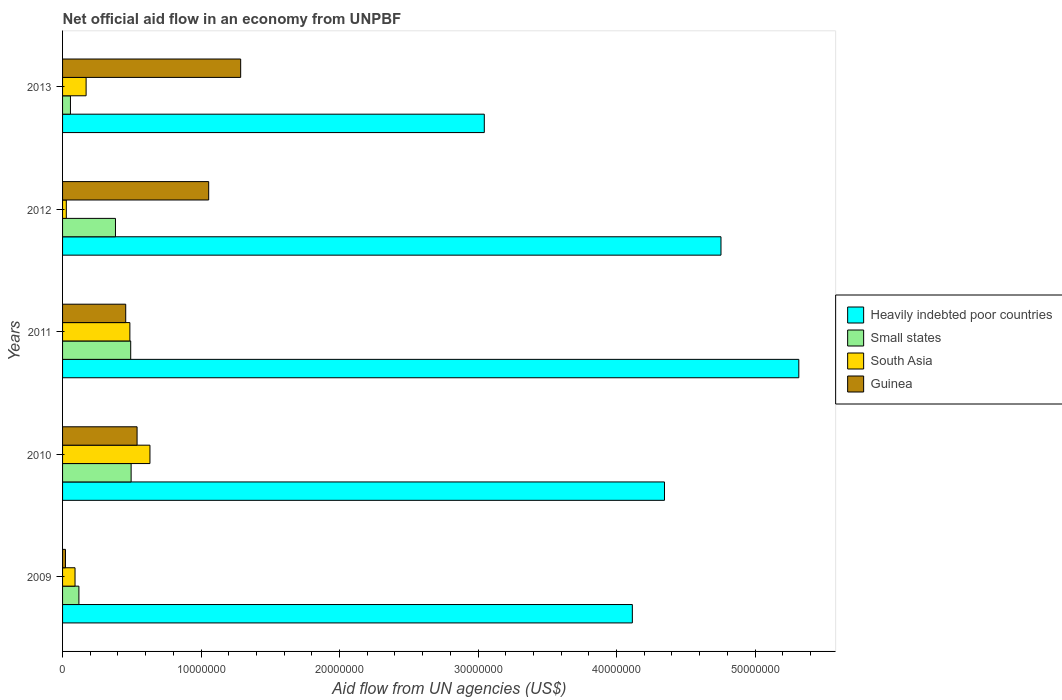How many groups of bars are there?
Offer a very short reply. 5. Are the number of bars per tick equal to the number of legend labels?
Ensure brevity in your answer.  Yes. How many bars are there on the 2nd tick from the bottom?
Keep it short and to the point. 4. In how many cases, is the number of bars for a given year not equal to the number of legend labels?
Provide a short and direct response. 0. What is the net official aid flow in Heavily indebted poor countries in 2009?
Your answer should be very brief. 4.11e+07. Across all years, what is the maximum net official aid flow in South Asia?
Offer a terse response. 6.31e+06. Across all years, what is the minimum net official aid flow in Small states?
Provide a succinct answer. 5.70e+05. In which year was the net official aid flow in Guinea minimum?
Your answer should be very brief. 2009. What is the total net official aid flow in Guinea in the graph?
Offer a terse response. 3.36e+07. What is the difference between the net official aid flow in South Asia in 2009 and that in 2011?
Offer a very short reply. -3.96e+06. What is the difference between the net official aid flow in Guinea in 2010 and the net official aid flow in Small states in 2011?
Keep it short and to the point. 4.60e+05. What is the average net official aid flow in Guinea per year?
Provide a succinct answer. 6.71e+06. In the year 2010, what is the difference between the net official aid flow in Heavily indebted poor countries and net official aid flow in Small states?
Make the answer very short. 3.85e+07. What is the ratio of the net official aid flow in Guinea in 2009 to that in 2013?
Provide a succinct answer. 0.02. Is the difference between the net official aid flow in Heavily indebted poor countries in 2010 and 2011 greater than the difference between the net official aid flow in Small states in 2010 and 2011?
Offer a terse response. No. What is the difference between the highest and the second highest net official aid flow in Heavily indebted poor countries?
Your answer should be compact. 5.62e+06. What is the difference between the highest and the lowest net official aid flow in Heavily indebted poor countries?
Your response must be concise. 2.27e+07. Is it the case that in every year, the sum of the net official aid flow in Small states and net official aid flow in Guinea is greater than the sum of net official aid flow in South Asia and net official aid flow in Heavily indebted poor countries?
Give a very brief answer. No. What does the 4th bar from the bottom in 2009 represents?
Your response must be concise. Guinea. Is it the case that in every year, the sum of the net official aid flow in Small states and net official aid flow in Heavily indebted poor countries is greater than the net official aid flow in South Asia?
Offer a terse response. Yes. How many years are there in the graph?
Offer a very short reply. 5. Does the graph contain grids?
Make the answer very short. No. Where does the legend appear in the graph?
Give a very brief answer. Center right. How are the legend labels stacked?
Your answer should be compact. Vertical. What is the title of the graph?
Keep it short and to the point. Net official aid flow in an economy from UNPBF. Does "Mongolia" appear as one of the legend labels in the graph?
Your response must be concise. No. What is the label or title of the X-axis?
Offer a terse response. Aid flow from UN agencies (US$). What is the Aid flow from UN agencies (US$) of Heavily indebted poor countries in 2009?
Make the answer very short. 4.11e+07. What is the Aid flow from UN agencies (US$) of Small states in 2009?
Provide a short and direct response. 1.18e+06. What is the Aid flow from UN agencies (US$) of South Asia in 2009?
Your answer should be very brief. 9.00e+05. What is the Aid flow from UN agencies (US$) of Heavily indebted poor countries in 2010?
Your answer should be compact. 4.35e+07. What is the Aid flow from UN agencies (US$) in Small states in 2010?
Offer a very short reply. 4.95e+06. What is the Aid flow from UN agencies (US$) in South Asia in 2010?
Make the answer very short. 6.31e+06. What is the Aid flow from UN agencies (US$) in Guinea in 2010?
Your answer should be very brief. 5.38e+06. What is the Aid flow from UN agencies (US$) of Heavily indebted poor countries in 2011?
Make the answer very short. 5.32e+07. What is the Aid flow from UN agencies (US$) of Small states in 2011?
Provide a succinct answer. 4.92e+06. What is the Aid flow from UN agencies (US$) of South Asia in 2011?
Keep it short and to the point. 4.86e+06. What is the Aid flow from UN agencies (US$) in Guinea in 2011?
Your answer should be very brief. 4.56e+06. What is the Aid flow from UN agencies (US$) in Heavily indebted poor countries in 2012?
Provide a succinct answer. 4.75e+07. What is the Aid flow from UN agencies (US$) of Small states in 2012?
Ensure brevity in your answer.  3.82e+06. What is the Aid flow from UN agencies (US$) in South Asia in 2012?
Make the answer very short. 2.70e+05. What is the Aid flow from UN agencies (US$) in Guinea in 2012?
Your answer should be compact. 1.06e+07. What is the Aid flow from UN agencies (US$) in Heavily indebted poor countries in 2013?
Ensure brevity in your answer.  3.04e+07. What is the Aid flow from UN agencies (US$) of Small states in 2013?
Provide a short and direct response. 5.70e+05. What is the Aid flow from UN agencies (US$) of South Asia in 2013?
Make the answer very short. 1.70e+06. What is the Aid flow from UN agencies (US$) in Guinea in 2013?
Provide a succinct answer. 1.29e+07. Across all years, what is the maximum Aid flow from UN agencies (US$) of Heavily indebted poor countries?
Offer a very short reply. 5.32e+07. Across all years, what is the maximum Aid flow from UN agencies (US$) of Small states?
Provide a succinct answer. 4.95e+06. Across all years, what is the maximum Aid flow from UN agencies (US$) of South Asia?
Your answer should be very brief. 6.31e+06. Across all years, what is the maximum Aid flow from UN agencies (US$) in Guinea?
Offer a very short reply. 1.29e+07. Across all years, what is the minimum Aid flow from UN agencies (US$) in Heavily indebted poor countries?
Offer a very short reply. 3.04e+07. Across all years, what is the minimum Aid flow from UN agencies (US$) in Small states?
Keep it short and to the point. 5.70e+05. Across all years, what is the minimum Aid flow from UN agencies (US$) in South Asia?
Offer a terse response. 2.70e+05. Across all years, what is the minimum Aid flow from UN agencies (US$) in Guinea?
Your answer should be compact. 2.10e+05. What is the total Aid flow from UN agencies (US$) in Heavily indebted poor countries in the graph?
Your answer should be very brief. 2.16e+08. What is the total Aid flow from UN agencies (US$) of Small states in the graph?
Your answer should be very brief. 1.54e+07. What is the total Aid flow from UN agencies (US$) of South Asia in the graph?
Offer a very short reply. 1.40e+07. What is the total Aid flow from UN agencies (US$) in Guinea in the graph?
Offer a terse response. 3.36e+07. What is the difference between the Aid flow from UN agencies (US$) in Heavily indebted poor countries in 2009 and that in 2010?
Make the answer very short. -2.32e+06. What is the difference between the Aid flow from UN agencies (US$) in Small states in 2009 and that in 2010?
Provide a short and direct response. -3.77e+06. What is the difference between the Aid flow from UN agencies (US$) of South Asia in 2009 and that in 2010?
Provide a succinct answer. -5.41e+06. What is the difference between the Aid flow from UN agencies (US$) of Guinea in 2009 and that in 2010?
Your response must be concise. -5.17e+06. What is the difference between the Aid flow from UN agencies (US$) of Heavily indebted poor countries in 2009 and that in 2011?
Provide a short and direct response. -1.20e+07. What is the difference between the Aid flow from UN agencies (US$) of Small states in 2009 and that in 2011?
Offer a very short reply. -3.74e+06. What is the difference between the Aid flow from UN agencies (US$) of South Asia in 2009 and that in 2011?
Make the answer very short. -3.96e+06. What is the difference between the Aid flow from UN agencies (US$) of Guinea in 2009 and that in 2011?
Give a very brief answer. -4.35e+06. What is the difference between the Aid flow from UN agencies (US$) in Heavily indebted poor countries in 2009 and that in 2012?
Keep it short and to the point. -6.40e+06. What is the difference between the Aid flow from UN agencies (US$) of Small states in 2009 and that in 2012?
Offer a terse response. -2.64e+06. What is the difference between the Aid flow from UN agencies (US$) of South Asia in 2009 and that in 2012?
Keep it short and to the point. 6.30e+05. What is the difference between the Aid flow from UN agencies (US$) of Guinea in 2009 and that in 2012?
Your answer should be very brief. -1.03e+07. What is the difference between the Aid flow from UN agencies (US$) in Heavily indebted poor countries in 2009 and that in 2013?
Offer a terse response. 1.07e+07. What is the difference between the Aid flow from UN agencies (US$) of Small states in 2009 and that in 2013?
Provide a succinct answer. 6.10e+05. What is the difference between the Aid flow from UN agencies (US$) of South Asia in 2009 and that in 2013?
Provide a succinct answer. -8.00e+05. What is the difference between the Aid flow from UN agencies (US$) of Guinea in 2009 and that in 2013?
Make the answer very short. -1.26e+07. What is the difference between the Aid flow from UN agencies (US$) in Heavily indebted poor countries in 2010 and that in 2011?
Provide a succinct answer. -9.70e+06. What is the difference between the Aid flow from UN agencies (US$) in Small states in 2010 and that in 2011?
Offer a terse response. 3.00e+04. What is the difference between the Aid flow from UN agencies (US$) of South Asia in 2010 and that in 2011?
Keep it short and to the point. 1.45e+06. What is the difference between the Aid flow from UN agencies (US$) of Guinea in 2010 and that in 2011?
Provide a short and direct response. 8.20e+05. What is the difference between the Aid flow from UN agencies (US$) of Heavily indebted poor countries in 2010 and that in 2012?
Offer a very short reply. -4.08e+06. What is the difference between the Aid flow from UN agencies (US$) of Small states in 2010 and that in 2012?
Offer a very short reply. 1.13e+06. What is the difference between the Aid flow from UN agencies (US$) in South Asia in 2010 and that in 2012?
Your response must be concise. 6.04e+06. What is the difference between the Aid flow from UN agencies (US$) of Guinea in 2010 and that in 2012?
Ensure brevity in your answer.  -5.17e+06. What is the difference between the Aid flow from UN agencies (US$) in Heavily indebted poor countries in 2010 and that in 2013?
Give a very brief answer. 1.30e+07. What is the difference between the Aid flow from UN agencies (US$) of Small states in 2010 and that in 2013?
Provide a short and direct response. 4.38e+06. What is the difference between the Aid flow from UN agencies (US$) of South Asia in 2010 and that in 2013?
Your response must be concise. 4.61e+06. What is the difference between the Aid flow from UN agencies (US$) in Guinea in 2010 and that in 2013?
Offer a very short reply. -7.48e+06. What is the difference between the Aid flow from UN agencies (US$) of Heavily indebted poor countries in 2011 and that in 2012?
Your response must be concise. 5.62e+06. What is the difference between the Aid flow from UN agencies (US$) of Small states in 2011 and that in 2012?
Provide a short and direct response. 1.10e+06. What is the difference between the Aid flow from UN agencies (US$) of South Asia in 2011 and that in 2012?
Provide a succinct answer. 4.59e+06. What is the difference between the Aid flow from UN agencies (US$) of Guinea in 2011 and that in 2012?
Keep it short and to the point. -5.99e+06. What is the difference between the Aid flow from UN agencies (US$) of Heavily indebted poor countries in 2011 and that in 2013?
Your answer should be compact. 2.27e+07. What is the difference between the Aid flow from UN agencies (US$) in Small states in 2011 and that in 2013?
Your response must be concise. 4.35e+06. What is the difference between the Aid flow from UN agencies (US$) of South Asia in 2011 and that in 2013?
Provide a short and direct response. 3.16e+06. What is the difference between the Aid flow from UN agencies (US$) of Guinea in 2011 and that in 2013?
Keep it short and to the point. -8.30e+06. What is the difference between the Aid flow from UN agencies (US$) of Heavily indebted poor countries in 2012 and that in 2013?
Provide a succinct answer. 1.71e+07. What is the difference between the Aid flow from UN agencies (US$) of Small states in 2012 and that in 2013?
Your response must be concise. 3.25e+06. What is the difference between the Aid flow from UN agencies (US$) in South Asia in 2012 and that in 2013?
Provide a short and direct response. -1.43e+06. What is the difference between the Aid flow from UN agencies (US$) in Guinea in 2012 and that in 2013?
Provide a succinct answer. -2.31e+06. What is the difference between the Aid flow from UN agencies (US$) of Heavily indebted poor countries in 2009 and the Aid flow from UN agencies (US$) of Small states in 2010?
Ensure brevity in your answer.  3.62e+07. What is the difference between the Aid flow from UN agencies (US$) in Heavily indebted poor countries in 2009 and the Aid flow from UN agencies (US$) in South Asia in 2010?
Make the answer very short. 3.48e+07. What is the difference between the Aid flow from UN agencies (US$) of Heavily indebted poor countries in 2009 and the Aid flow from UN agencies (US$) of Guinea in 2010?
Offer a very short reply. 3.58e+07. What is the difference between the Aid flow from UN agencies (US$) in Small states in 2009 and the Aid flow from UN agencies (US$) in South Asia in 2010?
Your response must be concise. -5.13e+06. What is the difference between the Aid flow from UN agencies (US$) of Small states in 2009 and the Aid flow from UN agencies (US$) of Guinea in 2010?
Your answer should be compact. -4.20e+06. What is the difference between the Aid flow from UN agencies (US$) of South Asia in 2009 and the Aid flow from UN agencies (US$) of Guinea in 2010?
Give a very brief answer. -4.48e+06. What is the difference between the Aid flow from UN agencies (US$) in Heavily indebted poor countries in 2009 and the Aid flow from UN agencies (US$) in Small states in 2011?
Give a very brief answer. 3.62e+07. What is the difference between the Aid flow from UN agencies (US$) of Heavily indebted poor countries in 2009 and the Aid flow from UN agencies (US$) of South Asia in 2011?
Keep it short and to the point. 3.63e+07. What is the difference between the Aid flow from UN agencies (US$) in Heavily indebted poor countries in 2009 and the Aid flow from UN agencies (US$) in Guinea in 2011?
Your answer should be compact. 3.66e+07. What is the difference between the Aid flow from UN agencies (US$) in Small states in 2009 and the Aid flow from UN agencies (US$) in South Asia in 2011?
Your response must be concise. -3.68e+06. What is the difference between the Aid flow from UN agencies (US$) in Small states in 2009 and the Aid flow from UN agencies (US$) in Guinea in 2011?
Make the answer very short. -3.38e+06. What is the difference between the Aid flow from UN agencies (US$) of South Asia in 2009 and the Aid flow from UN agencies (US$) of Guinea in 2011?
Provide a succinct answer. -3.66e+06. What is the difference between the Aid flow from UN agencies (US$) in Heavily indebted poor countries in 2009 and the Aid flow from UN agencies (US$) in Small states in 2012?
Your answer should be compact. 3.73e+07. What is the difference between the Aid flow from UN agencies (US$) of Heavily indebted poor countries in 2009 and the Aid flow from UN agencies (US$) of South Asia in 2012?
Offer a terse response. 4.09e+07. What is the difference between the Aid flow from UN agencies (US$) of Heavily indebted poor countries in 2009 and the Aid flow from UN agencies (US$) of Guinea in 2012?
Give a very brief answer. 3.06e+07. What is the difference between the Aid flow from UN agencies (US$) in Small states in 2009 and the Aid flow from UN agencies (US$) in South Asia in 2012?
Make the answer very short. 9.10e+05. What is the difference between the Aid flow from UN agencies (US$) in Small states in 2009 and the Aid flow from UN agencies (US$) in Guinea in 2012?
Offer a very short reply. -9.37e+06. What is the difference between the Aid flow from UN agencies (US$) in South Asia in 2009 and the Aid flow from UN agencies (US$) in Guinea in 2012?
Give a very brief answer. -9.65e+06. What is the difference between the Aid flow from UN agencies (US$) of Heavily indebted poor countries in 2009 and the Aid flow from UN agencies (US$) of Small states in 2013?
Keep it short and to the point. 4.06e+07. What is the difference between the Aid flow from UN agencies (US$) of Heavily indebted poor countries in 2009 and the Aid flow from UN agencies (US$) of South Asia in 2013?
Make the answer very short. 3.94e+07. What is the difference between the Aid flow from UN agencies (US$) of Heavily indebted poor countries in 2009 and the Aid flow from UN agencies (US$) of Guinea in 2013?
Your response must be concise. 2.83e+07. What is the difference between the Aid flow from UN agencies (US$) of Small states in 2009 and the Aid flow from UN agencies (US$) of South Asia in 2013?
Keep it short and to the point. -5.20e+05. What is the difference between the Aid flow from UN agencies (US$) in Small states in 2009 and the Aid flow from UN agencies (US$) in Guinea in 2013?
Provide a short and direct response. -1.17e+07. What is the difference between the Aid flow from UN agencies (US$) of South Asia in 2009 and the Aid flow from UN agencies (US$) of Guinea in 2013?
Ensure brevity in your answer.  -1.20e+07. What is the difference between the Aid flow from UN agencies (US$) of Heavily indebted poor countries in 2010 and the Aid flow from UN agencies (US$) of Small states in 2011?
Offer a terse response. 3.85e+07. What is the difference between the Aid flow from UN agencies (US$) in Heavily indebted poor countries in 2010 and the Aid flow from UN agencies (US$) in South Asia in 2011?
Your response must be concise. 3.86e+07. What is the difference between the Aid flow from UN agencies (US$) in Heavily indebted poor countries in 2010 and the Aid flow from UN agencies (US$) in Guinea in 2011?
Make the answer very short. 3.89e+07. What is the difference between the Aid flow from UN agencies (US$) in Small states in 2010 and the Aid flow from UN agencies (US$) in South Asia in 2011?
Your answer should be very brief. 9.00e+04. What is the difference between the Aid flow from UN agencies (US$) of Small states in 2010 and the Aid flow from UN agencies (US$) of Guinea in 2011?
Provide a short and direct response. 3.90e+05. What is the difference between the Aid flow from UN agencies (US$) of South Asia in 2010 and the Aid flow from UN agencies (US$) of Guinea in 2011?
Keep it short and to the point. 1.75e+06. What is the difference between the Aid flow from UN agencies (US$) of Heavily indebted poor countries in 2010 and the Aid flow from UN agencies (US$) of Small states in 2012?
Offer a very short reply. 3.96e+07. What is the difference between the Aid flow from UN agencies (US$) of Heavily indebted poor countries in 2010 and the Aid flow from UN agencies (US$) of South Asia in 2012?
Give a very brief answer. 4.32e+07. What is the difference between the Aid flow from UN agencies (US$) of Heavily indebted poor countries in 2010 and the Aid flow from UN agencies (US$) of Guinea in 2012?
Give a very brief answer. 3.29e+07. What is the difference between the Aid flow from UN agencies (US$) of Small states in 2010 and the Aid flow from UN agencies (US$) of South Asia in 2012?
Provide a short and direct response. 4.68e+06. What is the difference between the Aid flow from UN agencies (US$) of Small states in 2010 and the Aid flow from UN agencies (US$) of Guinea in 2012?
Your answer should be compact. -5.60e+06. What is the difference between the Aid flow from UN agencies (US$) of South Asia in 2010 and the Aid flow from UN agencies (US$) of Guinea in 2012?
Provide a short and direct response. -4.24e+06. What is the difference between the Aid flow from UN agencies (US$) of Heavily indebted poor countries in 2010 and the Aid flow from UN agencies (US$) of Small states in 2013?
Your response must be concise. 4.29e+07. What is the difference between the Aid flow from UN agencies (US$) of Heavily indebted poor countries in 2010 and the Aid flow from UN agencies (US$) of South Asia in 2013?
Make the answer very short. 4.18e+07. What is the difference between the Aid flow from UN agencies (US$) of Heavily indebted poor countries in 2010 and the Aid flow from UN agencies (US$) of Guinea in 2013?
Offer a very short reply. 3.06e+07. What is the difference between the Aid flow from UN agencies (US$) in Small states in 2010 and the Aid flow from UN agencies (US$) in South Asia in 2013?
Make the answer very short. 3.25e+06. What is the difference between the Aid flow from UN agencies (US$) in Small states in 2010 and the Aid flow from UN agencies (US$) in Guinea in 2013?
Make the answer very short. -7.91e+06. What is the difference between the Aid flow from UN agencies (US$) in South Asia in 2010 and the Aid flow from UN agencies (US$) in Guinea in 2013?
Ensure brevity in your answer.  -6.55e+06. What is the difference between the Aid flow from UN agencies (US$) in Heavily indebted poor countries in 2011 and the Aid flow from UN agencies (US$) in Small states in 2012?
Provide a short and direct response. 4.93e+07. What is the difference between the Aid flow from UN agencies (US$) in Heavily indebted poor countries in 2011 and the Aid flow from UN agencies (US$) in South Asia in 2012?
Make the answer very short. 5.29e+07. What is the difference between the Aid flow from UN agencies (US$) in Heavily indebted poor countries in 2011 and the Aid flow from UN agencies (US$) in Guinea in 2012?
Ensure brevity in your answer.  4.26e+07. What is the difference between the Aid flow from UN agencies (US$) in Small states in 2011 and the Aid flow from UN agencies (US$) in South Asia in 2012?
Make the answer very short. 4.65e+06. What is the difference between the Aid flow from UN agencies (US$) in Small states in 2011 and the Aid flow from UN agencies (US$) in Guinea in 2012?
Offer a very short reply. -5.63e+06. What is the difference between the Aid flow from UN agencies (US$) of South Asia in 2011 and the Aid flow from UN agencies (US$) of Guinea in 2012?
Provide a short and direct response. -5.69e+06. What is the difference between the Aid flow from UN agencies (US$) of Heavily indebted poor countries in 2011 and the Aid flow from UN agencies (US$) of Small states in 2013?
Your response must be concise. 5.26e+07. What is the difference between the Aid flow from UN agencies (US$) of Heavily indebted poor countries in 2011 and the Aid flow from UN agencies (US$) of South Asia in 2013?
Offer a terse response. 5.15e+07. What is the difference between the Aid flow from UN agencies (US$) in Heavily indebted poor countries in 2011 and the Aid flow from UN agencies (US$) in Guinea in 2013?
Your answer should be compact. 4.03e+07. What is the difference between the Aid flow from UN agencies (US$) in Small states in 2011 and the Aid flow from UN agencies (US$) in South Asia in 2013?
Your answer should be compact. 3.22e+06. What is the difference between the Aid flow from UN agencies (US$) of Small states in 2011 and the Aid flow from UN agencies (US$) of Guinea in 2013?
Keep it short and to the point. -7.94e+06. What is the difference between the Aid flow from UN agencies (US$) of South Asia in 2011 and the Aid flow from UN agencies (US$) of Guinea in 2013?
Your response must be concise. -8.00e+06. What is the difference between the Aid flow from UN agencies (US$) of Heavily indebted poor countries in 2012 and the Aid flow from UN agencies (US$) of Small states in 2013?
Make the answer very short. 4.70e+07. What is the difference between the Aid flow from UN agencies (US$) of Heavily indebted poor countries in 2012 and the Aid flow from UN agencies (US$) of South Asia in 2013?
Make the answer very short. 4.58e+07. What is the difference between the Aid flow from UN agencies (US$) in Heavily indebted poor countries in 2012 and the Aid flow from UN agencies (US$) in Guinea in 2013?
Your answer should be compact. 3.47e+07. What is the difference between the Aid flow from UN agencies (US$) of Small states in 2012 and the Aid flow from UN agencies (US$) of South Asia in 2013?
Your answer should be compact. 2.12e+06. What is the difference between the Aid flow from UN agencies (US$) in Small states in 2012 and the Aid flow from UN agencies (US$) in Guinea in 2013?
Provide a succinct answer. -9.04e+06. What is the difference between the Aid flow from UN agencies (US$) of South Asia in 2012 and the Aid flow from UN agencies (US$) of Guinea in 2013?
Provide a succinct answer. -1.26e+07. What is the average Aid flow from UN agencies (US$) of Heavily indebted poor countries per year?
Offer a very short reply. 4.32e+07. What is the average Aid flow from UN agencies (US$) of Small states per year?
Keep it short and to the point. 3.09e+06. What is the average Aid flow from UN agencies (US$) in South Asia per year?
Provide a succinct answer. 2.81e+06. What is the average Aid flow from UN agencies (US$) of Guinea per year?
Your answer should be very brief. 6.71e+06. In the year 2009, what is the difference between the Aid flow from UN agencies (US$) of Heavily indebted poor countries and Aid flow from UN agencies (US$) of Small states?
Provide a short and direct response. 4.00e+07. In the year 2009, what is the difference between the Aid flow from UN agencies (US$) in Heavily indebted poor countries and Aid flow from UN agencies (US$) in South Asia?
Make the answer very short. 4.02e+07. In the year 2009, what is the difference between the Aid flow from UN agencies (US$) in Heavily indebted poor countries and Aid flow from UN agencies (US$) in Guinea?
Provide a succinct answer. 4.09e+07. In the year 2009, what is the difference between the Aid flow from UN agencies (US$) in Small states and Aid flow from UN agencies (US$) in Guinea?
Provide a succinct answer. 9.70e+05. In the year 2009, what is the difference between the Aid flow from UN agencies (US$) of South Asia and Aid flow from UN agencies (US$) of Guinea?
Make the answer very short. 6.90e+05. In the year 2010, what is the difference between the Aid flow from UN agencies (US$) in Heavily indebted poor countries and Aid flow from UN agencies (US$) in Small states?
Your response must be concise. 3.85e+07. In the year 2010, what is the difference between the Aid flow from UN agencies (US$) of Heavily indebted poor countries and Aid flow from UN agencies (US$) of South Asia?
Your answer should be very brief. 3.72e+07. In the year 2010, what is the difference between the Aid flow from UN agencies (US$) of Heavily indebted poor countries and Aid flow from UN agencies (US$) of Guinea?
Keep it short and to the point. 3.81e+07. In the year 2010, what is the difference between the Aid flow from UN agencies (US$) of Small states and Aid flow from UN agencies (US$) of South Asia?
Your response must be concise. -1.36e+06. In the year 2010, what is the difference between the Aid flow from UN agencies (US$) in Small states and Aid flow from UN agencies (US$) in Guinea?
Your response must be concise. -4.30e+05. In the year 2010, what is the difference between the Aid flow from UN agencies (US$) of South Asia and Aid flow from UN agencies (US$) of Guinea?
Your answer should be very brief. 9.30e+05. In the year 2011, what is the difference between the Aid flow from UN agencies (US$) of Heavily indebted poor countries and Aid flow from UN agencies (US$) of Small states?
Your answer should be compact. 4.82e+07. In the year 2011, what is the difference between the Aid flow from UN agencies (US$) of Heavily indebted poor countries and Aid flow from UN agencies (US$) of South Asia?
Give a very brief answer. 4.83e+07. In the year 2011, what is the difference between the Aid flow from UN agencies (US$) in Heavily indebted poor countries and Aid flow from UN agencies (US$) in Guinea?
Your answer should be very brief. 4.86e+07. In the year 2011, what is the difference between the Aid flow from UN agencies (US$) of Small states and Aid flow from UN agencies (US$) of South Asia?
Provide a short and direct response. 6.00e+04. In the year 2011, what is the difference between the Aid flow from UN agencies (US$) in Small states and Aid flow from UN agencies (US$) in Guinea?
Provide a succinct answer. 3.60e+05. In the year 2011, what is the difference between the Aid flow from UN agencies (US$) in South Asia and Aid flow from UN agencies (US$) in Guinea?
Keep it short and to the point. 3.00e+05. In the year 2012, what is the difference between the Aid flow from UN agencies (US$) in Heavily indebted poor countries and Aid flow from UN agencies (US$) in Small states?
Provide a short and direct response. 4.37e+07. In the year 2012, what is the difference between the Aid flow from UN agencies (US$) of Heavily indebted poor countries and Aid flow from UN agencies (US$) of South Asia?
Your answer should be very brief. 4.73e+07. In the year 2012, what is the difference between the Aid flow from UN agencies (US$) of Heavily indebted poor countries and Aid flow from UN agencies (US$) of Guinea?
Ensure brevity in your answer.  3.70e+07. In the year 2012, what is the difference between the Aid flow from UN agencies (US$) in Small states and Aid flow from UN agencies (US$) in South Asia?
Keep it short and to the point. 3.55e+06. In the year 2012, what is the difference between the Aid flow from UN agencies (US$) of Small states and Aid flow from UN agencies (US$) of Guinea?
Offer a terse response. -6.73e+06. In the year 2012, what is the difference between the Aid flow from UN agencies (US$) of South Asia and Aid flow from UN agencies (US$) of Guinea?
Your response must be concise. -1.03e+07. In the year 2013, what is the difference between the Aid flow from UN agencies (US$) in Heavily indebted poor countries and Aid flow from UN agencies (US$) in Small states?
Ensure brevity in your answer.  2.99e+07. In the year 2013, what is the difference between the Aid flow from UN agencies (US$) in Heavily indebted poor countries and Aid flow from UN agencies (US$) in South Asia?
Offer a very short reply. 2.88e+07. In the year 2013, what is the difference between the Aid flow from UN agencies (US$) in Heavily indebted poor countries and Aid flow from UN agencies (US$) in Guinea?
Your answer should be compact. 1.76e+07. In the year 2013, what is the difference between the Aid flow from UN agencies (US$) of Small states and Aid flow from UN agencies (US$) of South Asia?
Ensure brevity in your answer.  -1.13e+06. In the year 2013, what is the difference between the Aid flow from UN agencies (US$) of Small states and Aid flow from UN agencies (US$) of Guinea?
Keep it short and to the point. -1.23e+07. In the year 2013, what is the difference between the Aid flow from UN agencies (US$) in South Asia and Aid flow from UN agencies (US$) in Guinea?
Offer a terse response. -1.12e+07. What is the ratio of the Aid flow from UN agencies (US$) in Heavily indebted poor countries in 2009 to that in 2010?
Your answer should be compact. 0.95. What is the ratio of the Aid flow from UN agencies (US$) in Small states in 2009 to that in 2010?
Provide a succinct answer. 0.24. What is the ratio of the Aid flow from UN agencies (US$) of South Asia in 2009 to that in 2010?
Offer a terse response. 0.14. What is the ratio of the Aid flow from UN agencies (US$) of Guinea in 2009 to that in 2010?
Give a very brief answer. 0.04. What is the ratio of the Aid flow from UN agencies (US$) of Heavily indebted poor countries in 2009 to that in 2011?
Your response must be concise. 0.77. What is the ratio of the Aid flow from UN agencies (US$) of Small states in 2009 to that in 2011?
Make the answer very short. 0.24. What is the ratio of the Aid flow from UN agencies (US$) of South Asia in 2009 to that in 2011?
Your answer should be compact. 0.19. What is the ratio of the Aid flow from UN agencies (US$) of Guinea in 2009 to that in 2011?
Your response must be concise. 0.05. What is the ratio of the Aid flow from UN agencies (US$) in Heavily indebted poor countries in 2009 to that in 2012?
Your response must be concise. 0.87. What is the ratio of the Aid flow from UN agencies (US$) in Small states in 2009 to that in 2012?
Your answer should be compact. 0.31. What is the ratio of the Aid flow from UN agencies (US$) of Guinea in 2009 to that in 2012?
Make the answer very short. 0.02. What is the ratio of the Aid flow from UN agencies (US$) of Heavily indebted poor countries in 2009 to that in 2013?
Your answer should be compact. 1.35. What is the ratio of the Aid flow from UN agencies (US$) of Small states in 2009 to that in 2013?
Give a very brief answer. 2.07. What is the ratio of the Aid flow from UN agencies (US$) of South Asia in 2009 to that in 2013?
Provide a succinct answer. 0.53. What is the ratio of the Aid flow from UN agencies (US$) in Guinea in 2009 to that in 2013?
Offer a terse response. 0.02. What is the ratio of the Aid flow from UN agencies (US$) in Heavily indebted poor countries in 2010 to that in 2011?
Provide a short and direct response. 0.82. What is the ratio of the Aid flow from UN agencies (US$) in Small states in 2010 to that in 2011?
Offer a very short reply. 1.01. What is the ratio of the Aid flow from UN agencies (US$) of South Asia in 2010 to that in 2011?
Your answer should be compact. 1.3. What is the ratio of the Aid flow from UN agencies (US$) of Guinea in 2010 to that in 2011?
Your answer should be very brief. 1.18. What is the ratio of the Aid flow from UN agencies (US$) in Heavily indebted poor countries in 2010 to that in 2012?
Offer a very short reply. 0.91. What is the ratio of the Aid flow from UN agencies (US$) in Small states in 2010 to that in 2012?
Your answer should be compact. 1.3. What is the ratio of the Aid flow from UN agencies (US$) of South Asia in 2010 to that in 2012?
Make the answer very short. 23.37. What is the ratio of the Aid flow from UN agencies (US$) in Guinea in 2010 to that in 2012?
Give a very brief answer. 0.51. What is the ratio of the Aid flow from UN agencies (US$) in Heavily indebted poor countries in 2010 to that in 2013?
Your answer should be compact. 1.43. What is the ratio of the Aid flow from UN agencies (US$) of Small states in 2010 to that in 2013?
Your response must be concise. 8.68. What is the ratio of the Aid flow from UN agencies (US$) of South Asia in 2010 to that in 2013?
Provide a short and direct response. 3.71. What is the ratio of the Aid flow from UN agencies (US$) in Guinea in 2010 to that in 2013?
Make the answer very short. 0.42. What is the ratio of the Aid flow from UN agencies (US$) of Heavily indebted poor countries in 2011 to that in 2012?
Ensure brevity in your answer.  1.12. What is the ratio of the Aid flow from UN agencies (US$) of Small states in 2011 to that in 2012?
Offer a terse response. 1.29. What is the ratio of the Aid flow from UN agencies (US$) of Guinea in 2011 to that in 2012?
Keep it short and to the point. 0.43. What is the ratio of the Aid flow from UN agencies (US$) of Heavily indebted poor countries in 2011 to that in 2013?
Give a very brief answer. 1.75. What is the ratio of the Aid flow from UN agencies (US$) of Small states in 2011 to that in 2013?
Offer a terse response. 8.63. What is the ratio of the Aid flow from UN agencies (US$) of South Asia in 2011 to that in 2013?
Make the answer very short. 2.86. What is the ratio of the Aid flow from UN agencies (US$) of Guinea in 2011 to that in 2013?
Your answer should be very brief. 0.35. What is the ratio of the Aid flow from UN agencies (US$) of Heavily indebted poor countries in 2012 to that in 2013?
Your response must be concise. 1.56. What is the ratio of the Aid flow from UN agencies (US$) in Small states in 2012 to that in 2013?
Offer a very short reply. 6.7. What is the ratio of the Aid flow from UN agencies (US$) of South Asia in 2012 to that in 2013?
Your answer should be compact. 0.16. What is the ratio of the Aid flow from UN agencies (US$) in Guinea in 2012 to that in 2013?
Offer a terse response. 0.82. What is the difference between the highest and the second highest Aid flow from UN agencies (US$) in Heavily indebted poor countries?
Your response must be concise. 5.62e+06. What is the difference between the highest and the second highest Aid flow from UN agencies (US$) in South Asia?
Give a very brief answer. 1.45e+06. What is the difference between the highest and the second highest Aid flow from UN agencies (US$) in Guinea?
Give a very brief answer. 2.31e+06. What is the difference between the highest and the lowest Aid flow from UN agencies (US$) of Heavily indebted poor countries?
Provide a succinct answer. 2.27e+07. What is the difference between the highest and the lowest Aid flow from UN agencies (US$) in Small states?
Provide a succinct answer. 4.38e+06. What is the difference between the highest and the lowest Aid flow from UN agencies (US$) of South Asia?
Keep it short and to the point. 6.04e+06. What is the difference between the highest and the lowest Aid flow from UN agencies (US$) in Guinea?
Your answer should be very brief. 1.26e+07. 